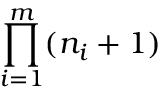Convert formula to latex. <formula><loc_0><loc_0><loc_500><loc_500>\prod _ { i = 1 } ^ { m } ( n _ { i } + 1 )</formula> 